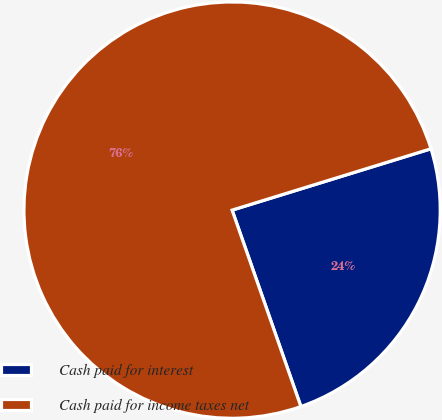<chart> <loc_0><loc_0><loc_500><loc_500><pie_chart><fcel>Cash paid for interest<fcel>Cash paid for income taxes net<nl><fcel>24.4%<fcel>75.6%<nl></chart> 